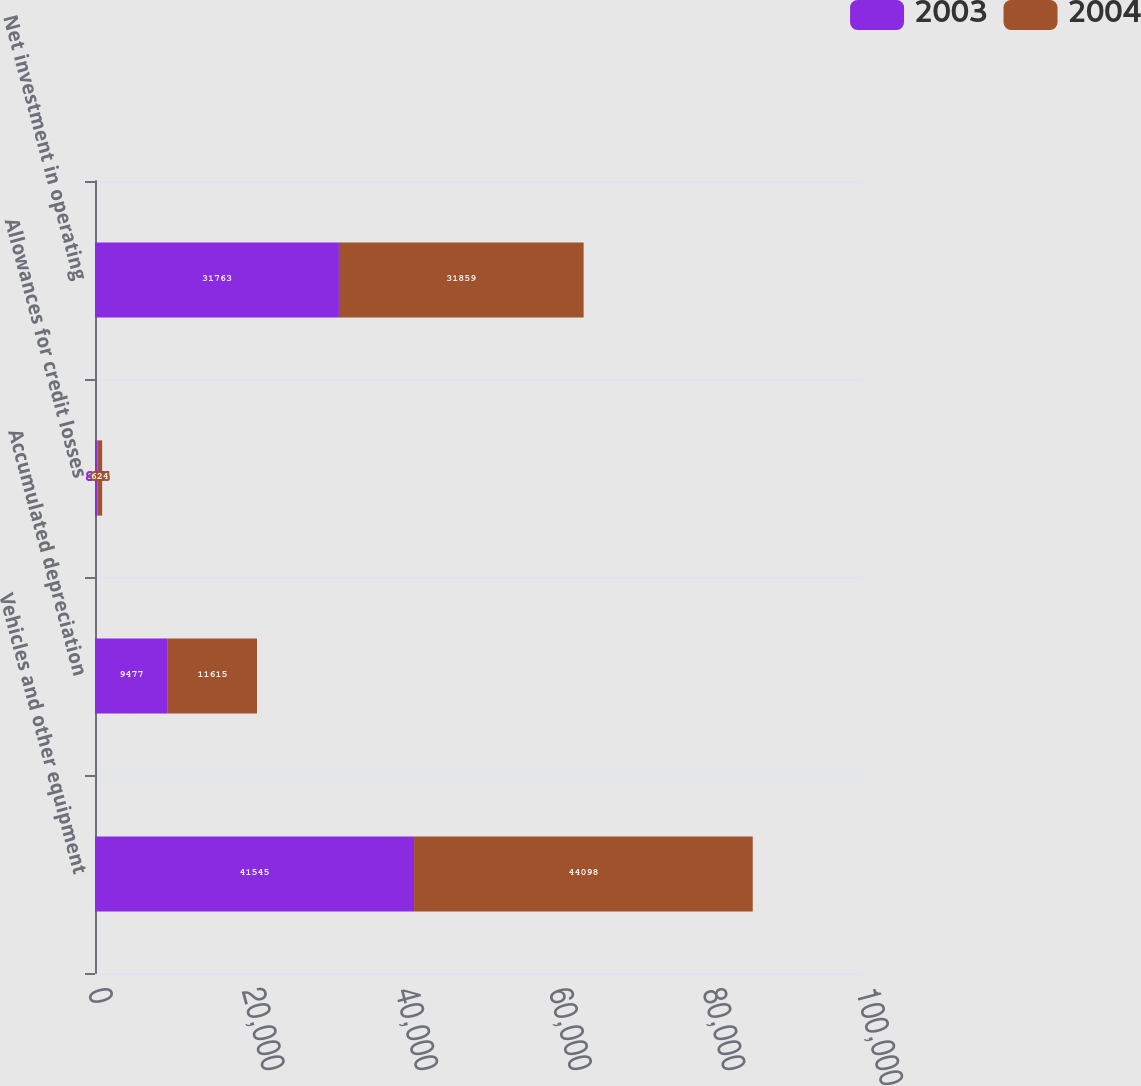Convert chart. <chart><loc_0><loc_0><loc_500><loc_500><stacked_bar_chart><ecel><fcel>Vehicles and other equipment<fcel>Accumulated depreciation<fcel>Allowances for credit losses<fcel>Net investment in operating<nl><fcel>2003<fcel>41545<fcel>9477<fcel>305<fcel>31763<nl><fcel>2004<fcel>44098<fcel>11615<fcel>624<fcel>31859<nl></chart> 